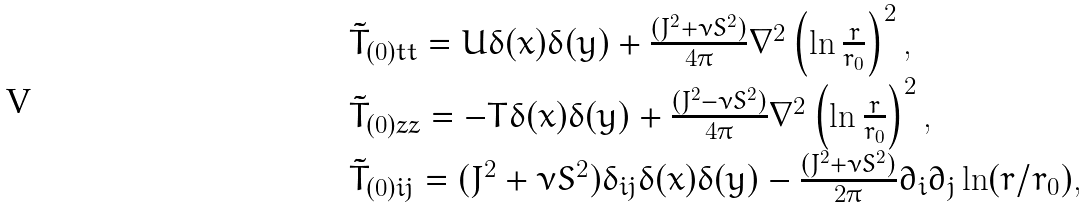Convert formula to latex. <formula><loc_0><loc_0><loc_500><loc_500>\begin{array} { l l } \tilde { T } _ { ( 0 ) t t } = U \delta ( x ) \delta ( y ) + \frac { ( J ^ { 2 } + \nu S ^ { 2 } ) } { 4 \pi } \nabla ^ { 2 } \left ( \ln \frac { r } { r _ { 0 } } \right ) ^ { 2 } , \\ \tilde { T } _ { ( 0 ) z z } = - T \delta ( x ) \delta ( y ) + \frac { ( J ^ { 2 } - \nu S ^ { 2 } ) } { 4 \pi } \nabla ^ { 2 } \left ( \ln \frac { r } { r _ { 0 } } \right ) ^ { 2 } , \\ \tilde { T } _ { ( 0 ) i j } = ( J ^ { 2 } + \nu S ^ { 2 } ) \delta _ { i j } \delta ( x ) \delta ( y ) - \frac { ( J ^ { 2 } + \nu S ^ { 2 } ) } { 2 \pi } \partial _ { i } \partial _ { j } \ln ( r / r _ { 0 } ) , \end{array}</formula> 